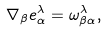<formula> <loc_0><loc_0><loc_500><loc_500>\nabla _ { \beta } e _ { \alpha } ^ { \lambda } = \omega _ { \beta \alpha } ^ { \lambda } ,</formula> 